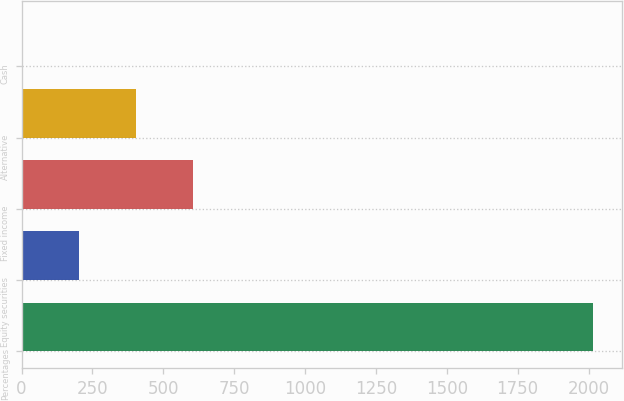Convert chart to OTSL. <chart><loc_0><loc_0><loc_500><loc_500><bar_chart><fcel>Percentages<fcel>Equity securities<fcel>Fixed income<fcel>Alternative<fcel>Cash<nl><fcel>2016<fcel>203.4<fcel>606.2<fcel>404.8<fcel>2<nl></chart> 